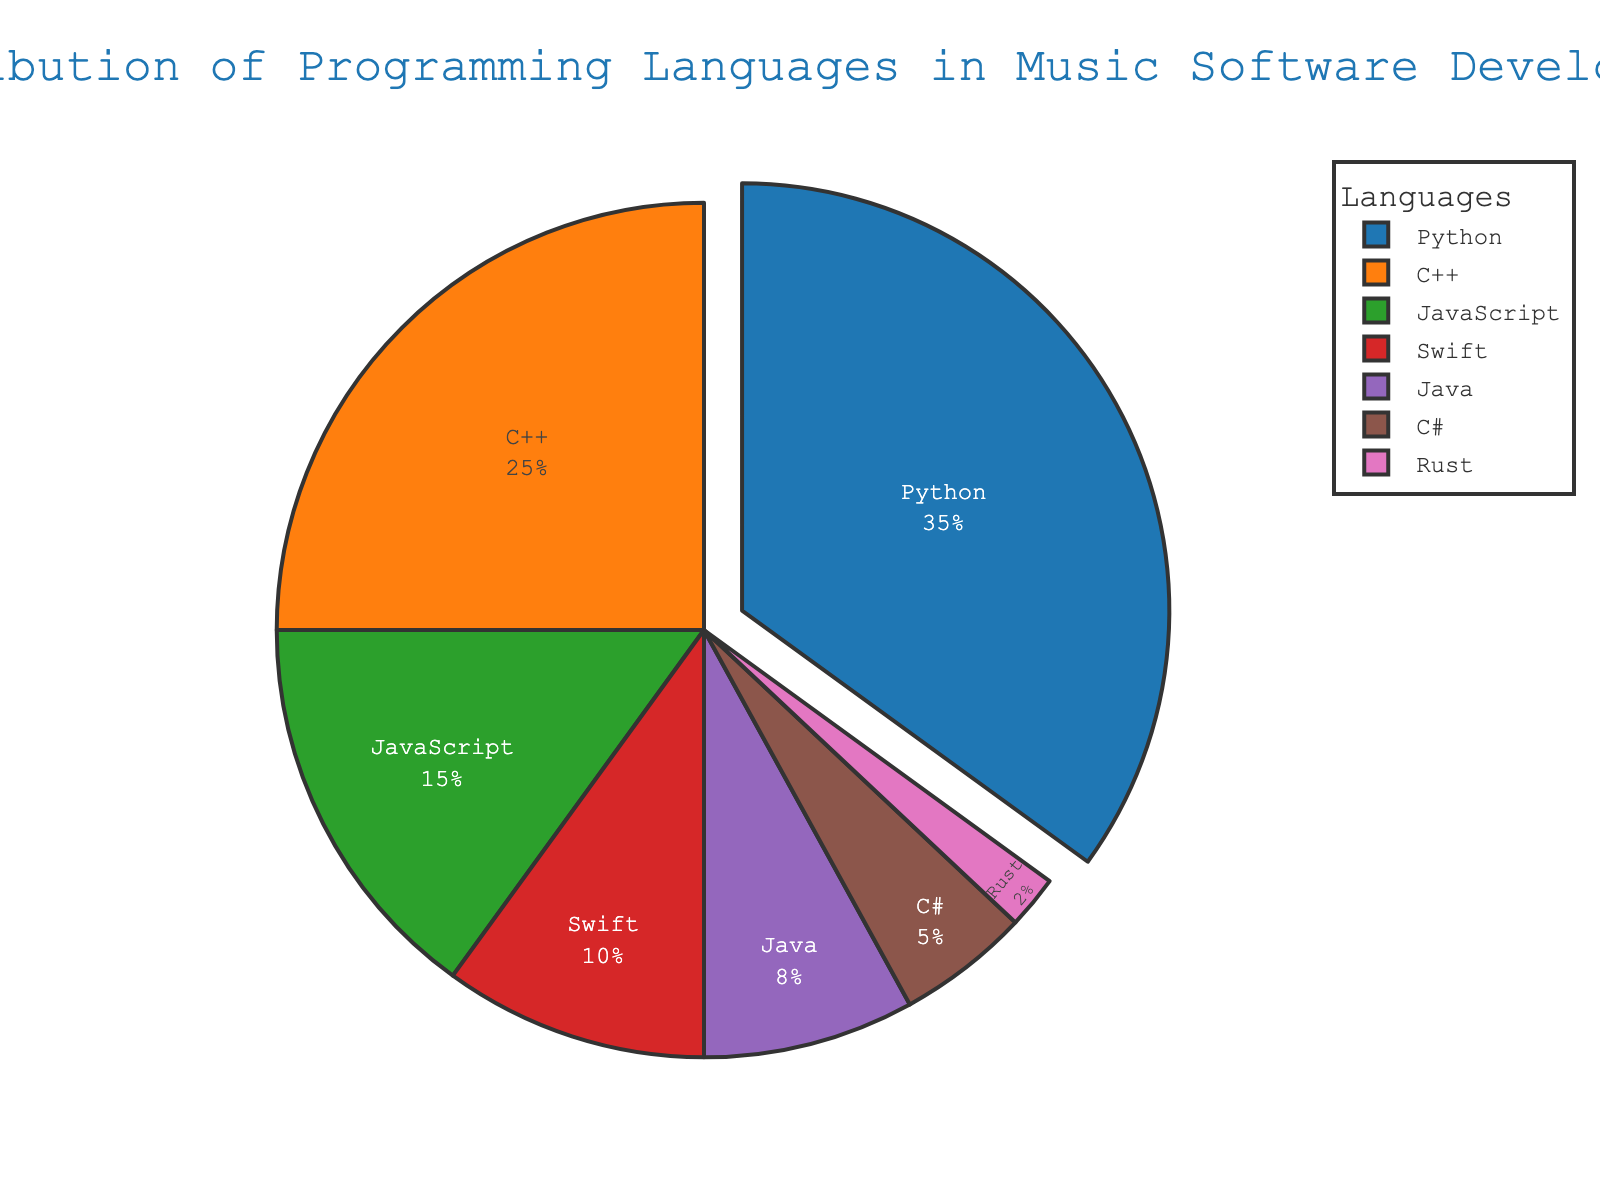What is the most commonly used programming language in music software development? The pie chart shows that Python has the largest slice, indicating it is used by 35% of developers.
Answer: Python Which language is used more, JavaScript or Swift? By looking at the sizes of the slices for JavaScript and Swift, it's clear that JavaScript has a larger percentage (15%) compared to Swift (10%).
Answer: JavaScript What is the combined percentage of usage for C++ and Java? The slice for C++ represents 25% and the slice for Java represents 8%. Adding these two percentages together gives us 33%.
Answer: 33% How much more is Python used compared to C#? Python is used by 35% of developers, whereas C# is used by 5%. Subtracting the percentage of C# from Python (35% - 5%) gives us 30%.
Answer: 30% Which programming language has the smallest slice in the pie chart? The pie chart shows that Rust has the smallest slice, representing 2% of the usage.
Answer: Rust What is the total percentage of usage for languages used by less than 10% of developers? The languages represented with less than 10% slices are Java (8%), C# (5%), and Rust (2%). Adding these percentages together gives us 15%.
Answer: 15% Which two languages combined have an equal proportion to Python's usage? Python accounts for 35%. Combining the percentages for C++ (25%) and Swift (10%) gives us 35%, which is equal to Python's usage.
Answer: C++ and Swift What percentage of the total usage do the three most popular languages constitute? The three most popular languages are Python (35%), C++ (25%), and JavaScript (15%). Adding these together gives us 75%.
Answer: 75% How does the percentage of Swift usage compare to the percentage of Rust usage? Swift usage is indicated at 10%, while Rust usage is 2%. Swift is used exactly 5 times more than Rust (10% / 2%).
Answer: 5 times more What color is the slice representing JavaScript? The pie chart uses a color palette, and the slice for JavaScript is the third slice, which is green.
Answer: Green 